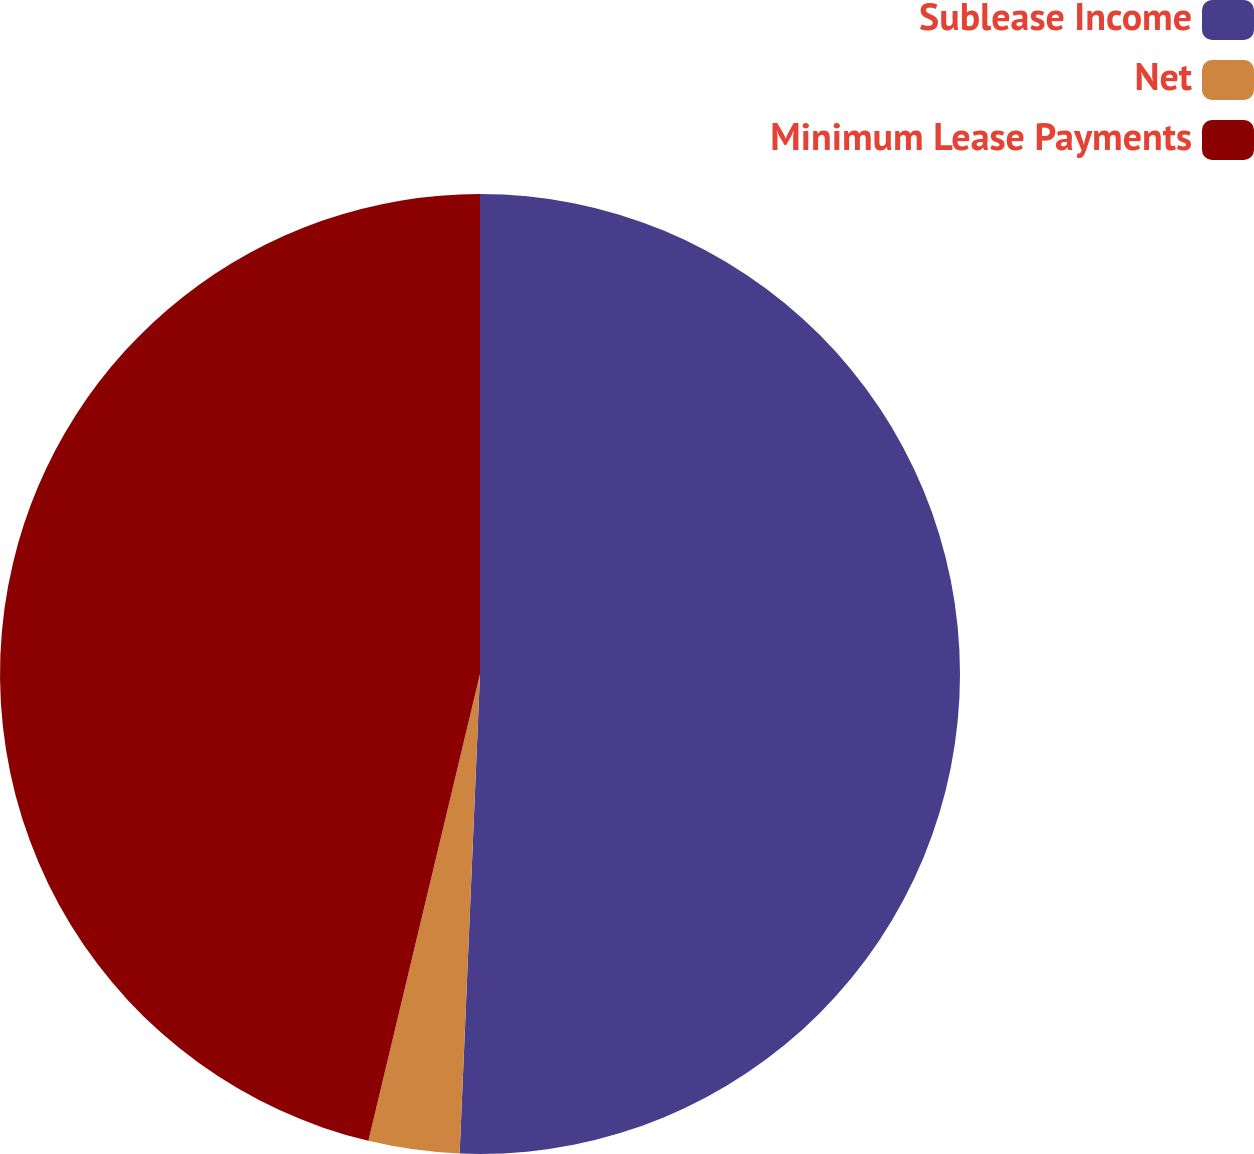Convert chart. <chart><loc_0><loc_0><loc_500><loc_500><pie_chart><fcel>Sublease Income<fcel>Net<fcel>Minimum Lease Payments<nl><fcel>50.68%<fcel>3.06%<fcel>46.27%<nl></chart> 